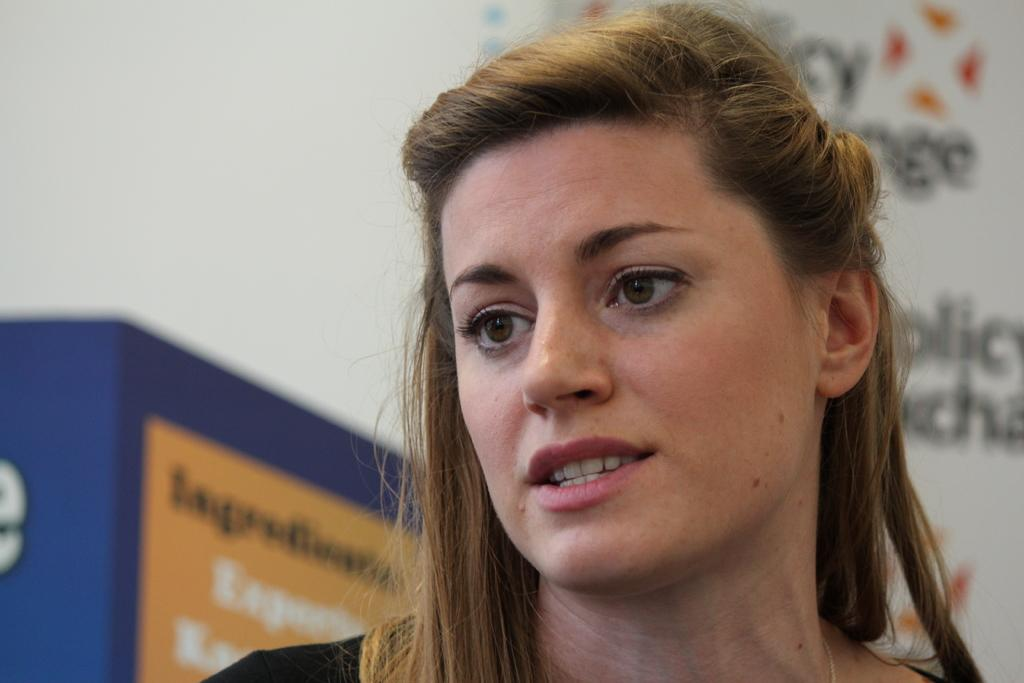What is the main subject of the image? The main subject of the image is a woman. What is the woman doing in the image? The woman is speaking in the image. Where is the woman located in the image? The woman is on the right side of the image. Can you describe the background of the image? The background of the image is blurred. How does the woman increase the distance between herself and the chalk in the image? There is no chalk present in the image, and therefore no such action can be observed. 